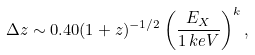<formula> <loc_0><loc_0><loc_500><loc_500>\Delta z \sim 0 . 4 0 ( 1 + z ) ^ { - 1 / 2 } \left ( \frac { E _ { X } } { 1 \, k e V } \right ) ^ { k } ,</formula> 